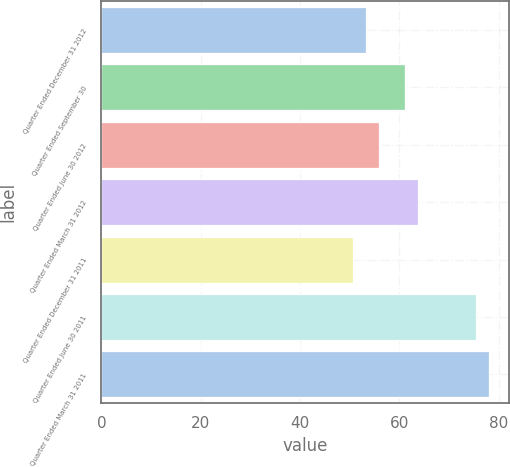Convert chart to OTSL. <chart><loc_0><loc_0><loc_500><loc_500><bar_chart><fcel>Quarter Ended December 31 2012<fcel>Quarter Ended September 30<fcel>Quarter Ended June 30 2012<fcel>Quarter Ended March 31 2012<fcel>Quarter Ended December 31 2011<fcel>Quarter Ended June 30 2011<fcel>Quarter Ended March 31 2011<nl><fcel>53.36<fcel>61.22<fcel>55.98<fcel>63.84<fcel>50.74<fcel>75.5<fcel>78.12<nl></chart> 